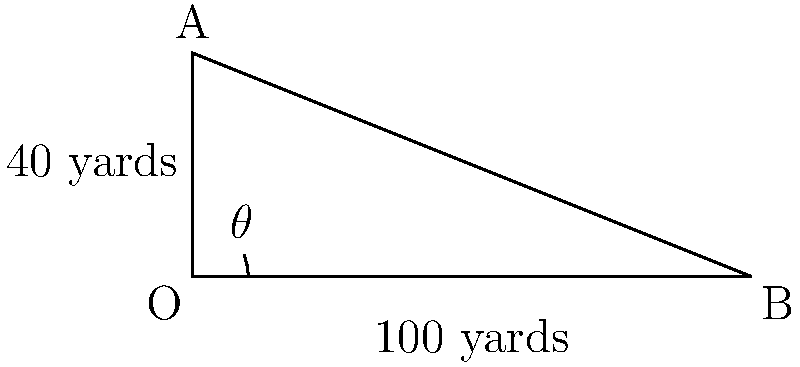In a crucial play, a quarterback throws a long pass from point O to a receiver at point B. The ball reaches a maximum height of 40 yards at point A. If the horizontal distance covered is 100 yards, what is the approximate launch angle $\theta$ of the pass? To solve this problem, we'll use trigonometry and the properties of a right triangle:

1. The trajectory forms a right triangle with vertices at O, A, and B.
2. We know the height (OA = 40 yards) and the horizontal distance (OB = 100 yards).
3. The launch angle $\theta$ is the angle between OB and the ground.

Let's calculate:

1. Use the tangent function: $\tan(\theta) = \frac{\text{opposite}}{\text{adjacent}} = \frac{OA}{OB}$
2. $\tan(\theta) = \frac{40}{100} = 0.4$
3. To find $\theta$, we need to use the inverse tangent (arctan) function:
   $\theta = \arctan(0.4)$
4. Using a calculator or trigonometric tables:
   $\theta \approx 21.8°$

Therefore, the approximate launch angle of the pass is 21.8°.
Answer: $21.8°$ 